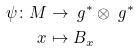Convert formula to latex. <formula><loc_0><loc_0><loc_500><loc_500>\psi \colon M & \rightarrow \ g ^ { * } \otimes \ g ^ { * } \\ x & \mapsto B _ { x }</formula> 